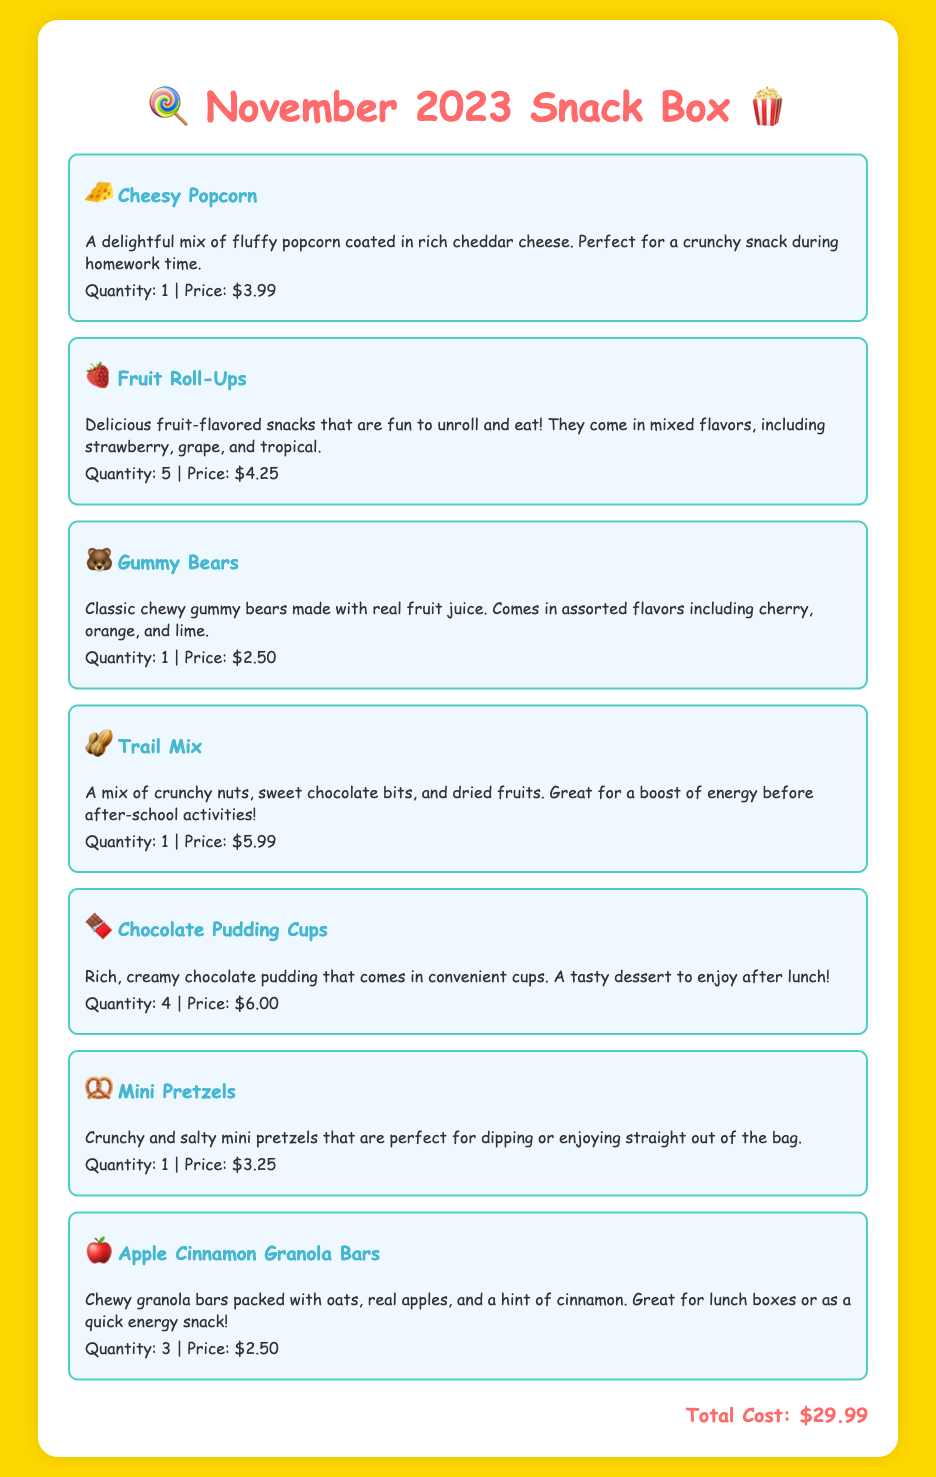What is the total cost of the snack box? The total cost is explicitly stated at the bottom of the document.
Answer: $29.99 How many varieties of snacks are included? The number of items listed in the document represents the varieties of snacks.
Answer: 7 What is the price of the Cheesy Popcorn? The price of the Cheesy Popcorn is provided in the item description.
Answer: $3.99 How many Chocolate Pudding Cups are in the box? The quantity for the Chocolate Pudding Cups is specified in the item's description.
Answer: 4 What type of fruit is mentioned in the Apple Cinnamon Granola Bars? The item description states the specific fruit used in the granola bars.
Answer: Apples Which snack has a teddy bear emoji? The emoji indicates the specific snack associated with it in the document.
Answer: Gummy Bears What is the quantity of Trail Mix in the box? The item description states the quantity for the Trail Mix.
Answer: 1 